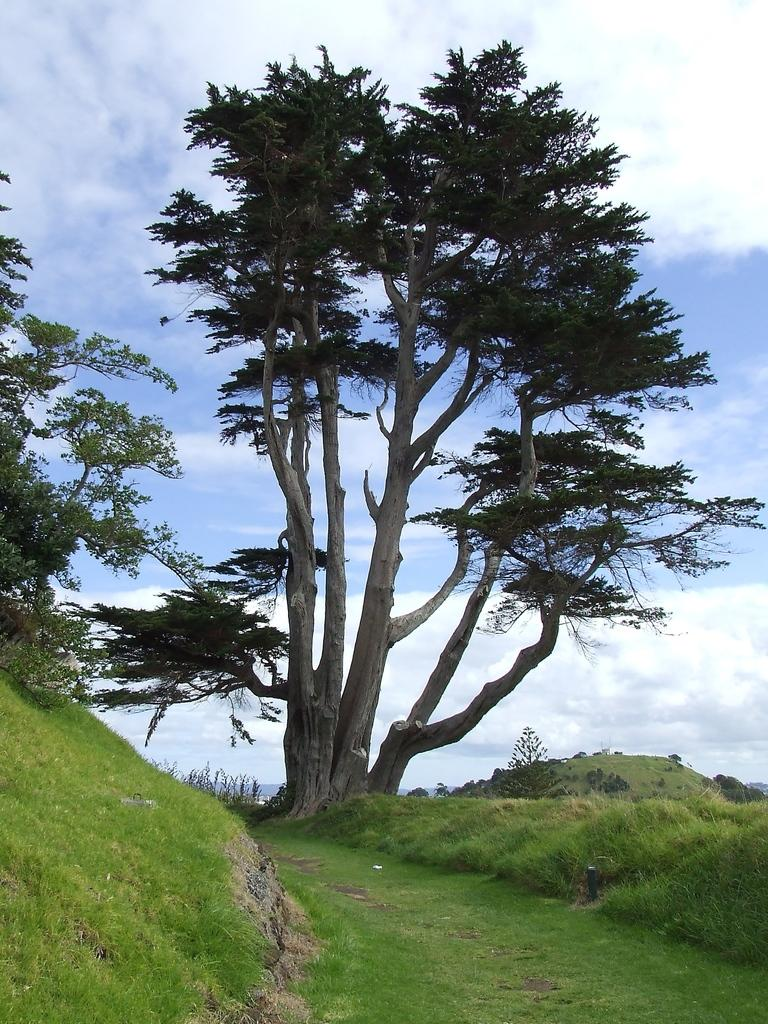What type of vegetation can be seen in the image? There is grass in the image. What other natural elements are present in the image? There are trees in the image. What can be seen in the sky in the image? There are clouds visible in the image. How many kites are flying in the image? There are no kites present in the image. What type of arithmetic problem can be solved using the trees in the image? The trees in the image are not related to any arithmetic problem, as they are simply part of the natural landscape. 